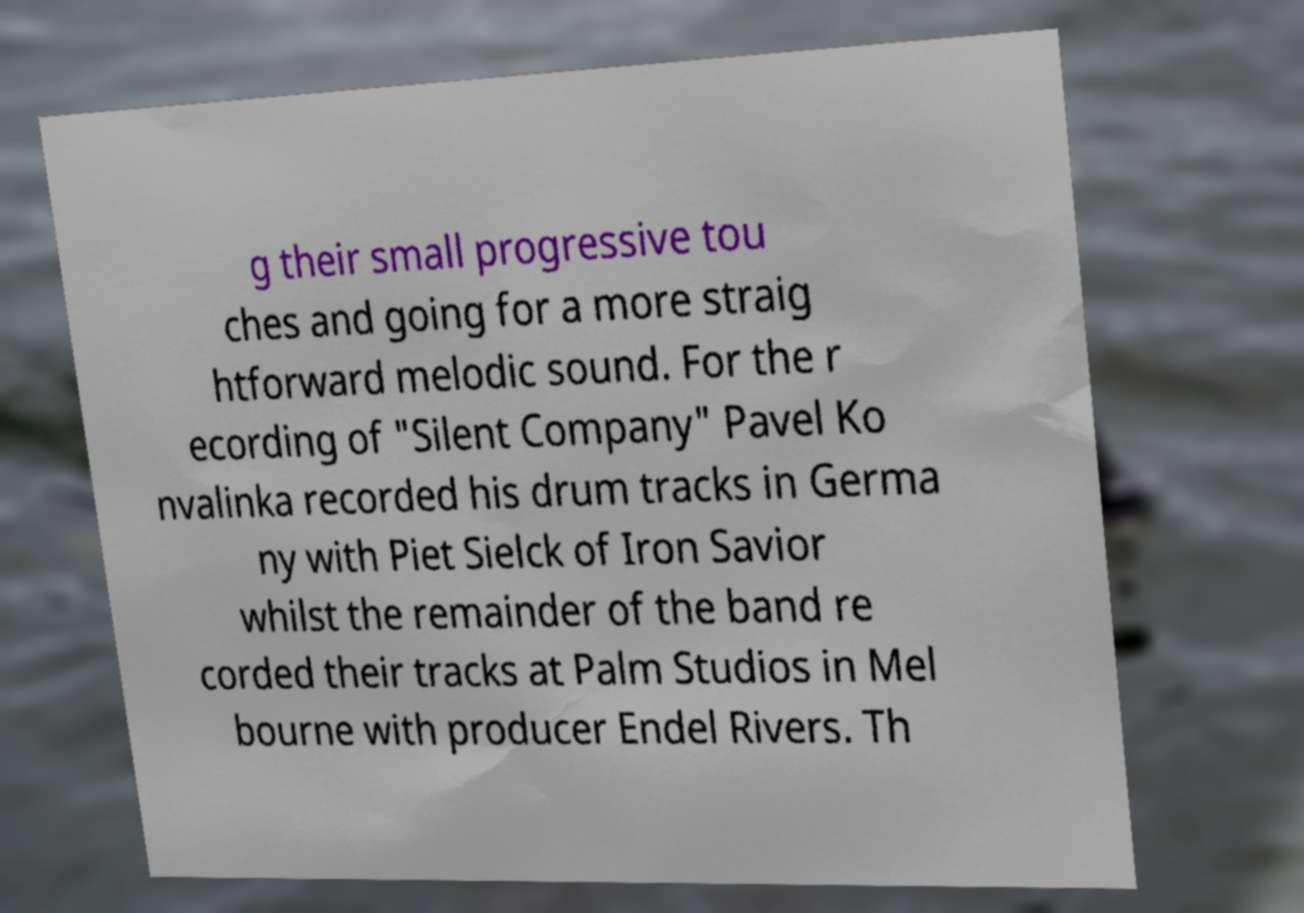There's text embedded in this image that I need extracted. Can you transcribe it verbatim? g their small progressive tou ches and going for a more straig htforward melodic sound. For the r ecording of "Silent Company" Pavel Ko nvalinka recorded his drum tracks in Germa ny with Piet Sielck of Iron Savior whilst the remainder of the band re corded their tracks at Palm Studios in Mel bourne with producer Endel Rivers. Th 